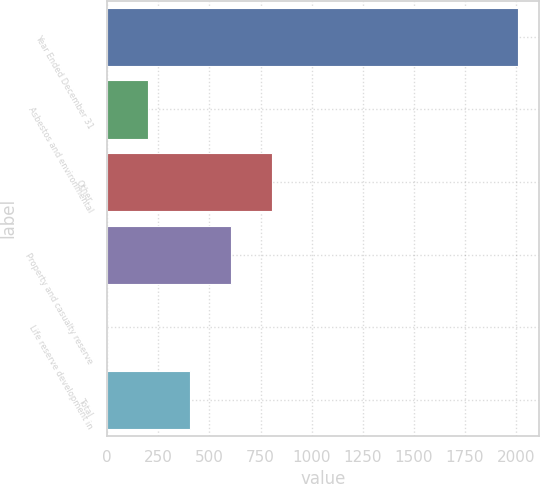<chart> <loc_0><loc_0><loc_500><loc_500><bar_chart><fcel>Year Ended December 31<fcel>Asbestos and environmental<fcel>Other<fcel>Property and casualty reserve<fcel>Life reserve development in<fcel>Total<nl><fcel>2009<fcel>201.8<fcel>804.2<fcel>603.4<fcel>1<fcel>402.6<nl></chart> 